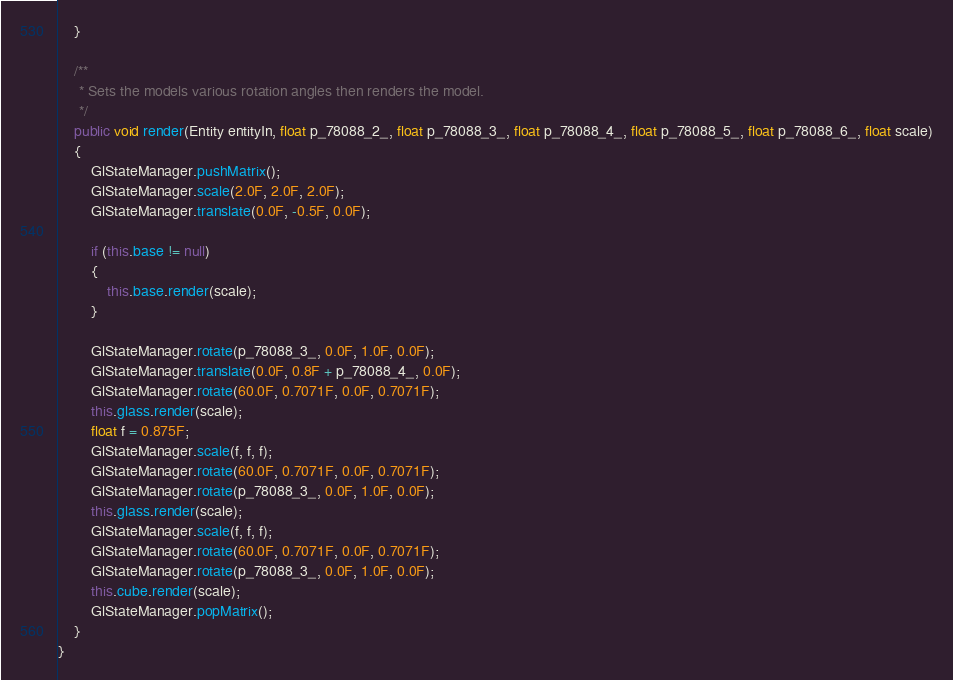Convert code to text. <code><loc_0><loc_0><loc_500><loc_500><_Java_>    }

    /**
     * Sets the models various rotation angles then renders the model.
     */
    public void render(Entity entityIn, float p_78088_2_, float p_78088_3_, float p_78088_4_, float p_78088_5_, float p_78088_6_, float scale)
    {
        GlStateManager.pushMatrix();
        GlStateManager.scale(2.0F, 2.0F, 2.0F);
        GlStateManager.translate(0.0F, -0.5F, 0.0F);

        if (this.base != null)
        {
            this.base.render(scale);
        }

        GlStateManager.rotate(p_78088_3_, 0.0F, 1.0F, 0.0F);
        GlStateManager.translate(0.0F, 0.8F + p_78088_4_, 0.0F);
        GlStateManager.rotate(60.0F, 0.7071F, 0.0F, 0.7071F);
        this.glass.render(scale);
        float f = 0.875F;
        GlStateManager.scale(f, f, f);
        GlStateManager.rotate(60.0F, 0.7071F, 0.0F, 0.7071F);
        GlStateManager.rotate(p_78088_3_, 0.0F, 1.0F, 0.0F);
        this.glass.render(scale);
        GlStateManager.scale(f, f, f);
        GlStateManager.rotate(60.0F, 0.7071F, 0.0F, 0.7071F);
        GlStateManager.rotate(p_78088_3_, 0.0F, 1.0F, 0.0F);
        this.cube.render(scale);
        GlStateManager.popMatrix();
    }
}</code> 